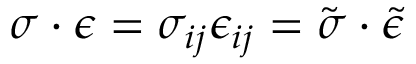<formula> <loc_0><loc_0><loc_500><loc_500>{ \sigma } \cdot { \epsilon } = \sigma _ { i j } \epsilon _ { i j } = { \tilde { \sigma } } \cdot { \tilde { \epsilon } }</formula> 